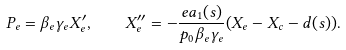Convert formula to latex. <formula><loc_0><loc_0><loc_500><loc_500>P _ { e } = \beta _ { e } \gamma _ { e } X _ { e } ^ { \prime } , \quad X _ { e } ^ { \prime \prime } = - { \frac { e a _ { 1 } ( s ) } { p _ { 0 } \beta _ { e } \gamma _ { e } } } { \left ( X _ { e } - X _ { c } - d ( s ) \right ) } .</formula> 